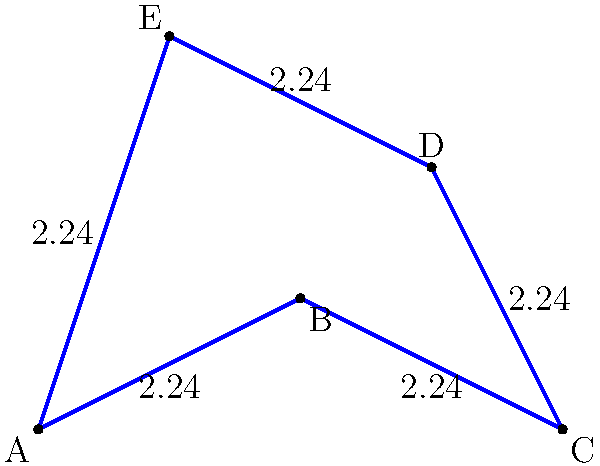In your latest vector illustration project, you've created a complex shape composed of connected line segments. Each segment measures exactly 2.24 units. Calculate the perimeter of this shape. How does this precise measurement in digital design compare to the potential variability in traditional painting techniques? To calculate the perimeter of this vector shape, we need to follow these steps:

1. Identify the number of line segments in the shape:
   The shape is a pentagon, which has 5 sides.

2. Determine the length of each segment:
   Each segment is stated to be exactly 2.24 units long.

3. Calculate the perimeter:
   Perimeter = Number of sides × Length of each side
              = 5 × 2.24
              = 11.2 units

4. Comparison to traditional painting:
   In vector design, we can achieve precise measurements like 2.24 units, which would be difficult to replicate consistently in traditional painting. This precision allows for exact scaling and reproduction across various media and sizes, a significant advantage in graphic design.

   Traditional painting techniques may introduce variability due to:
   - Brush stroke inconsistencies
   - Paint thickness variations
   - Canvas or paper texture influences
   - Human error in measurement and execution

   These factors could lead to slight differences in line lengths and overall perimeter in a traditional painting, whereas the vector illustration maintains perfect consistency.
Answer: 11.2 units 